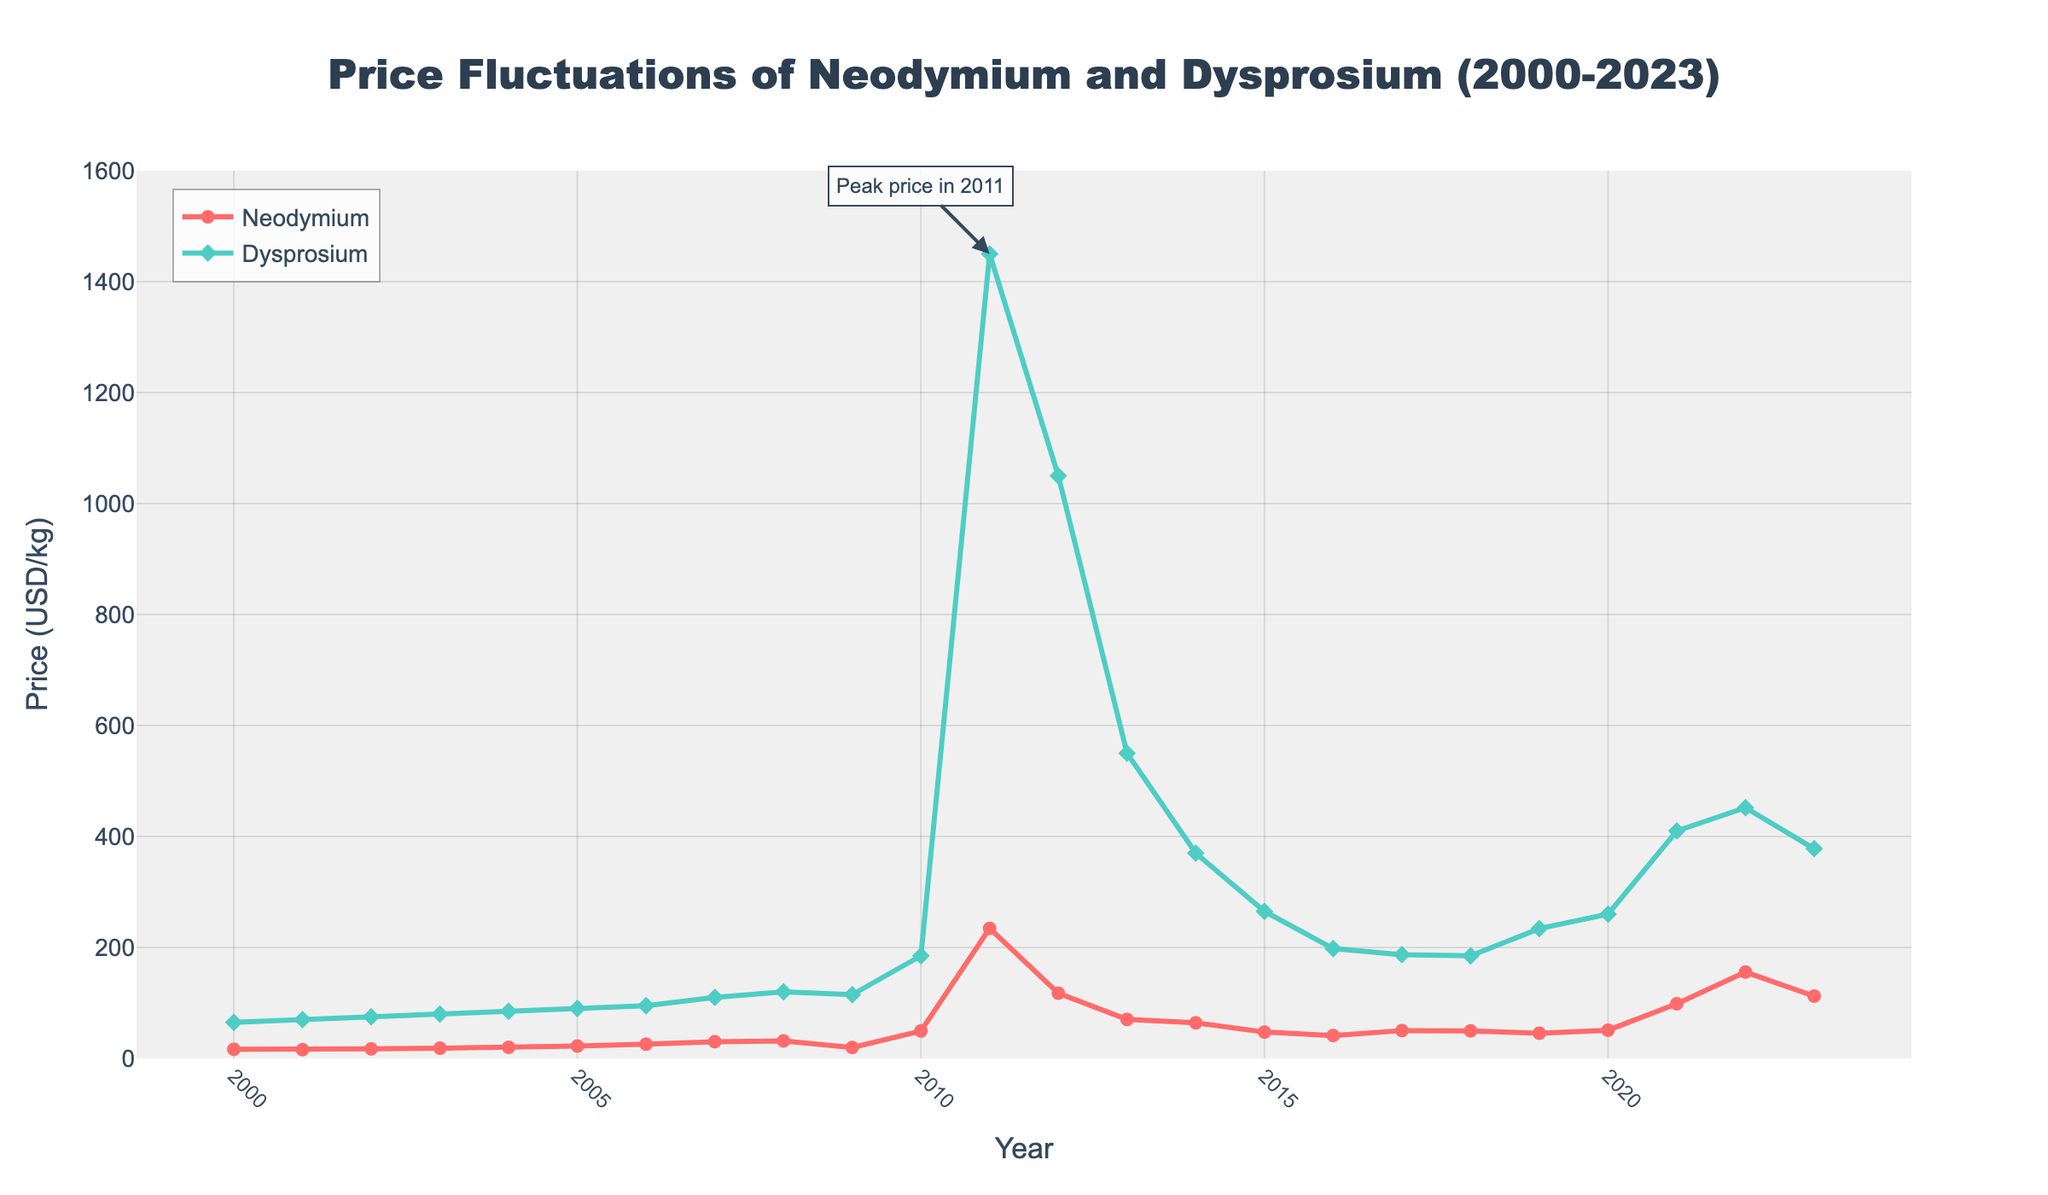What's the highest price of Dysprosium observed between 2000 and 2023? The peak price is indicated by a marked annotation pointing to the year 2011, where the price of Dysprosium reaches 1450 USD/kg.
Answer: 1450 USD/kg In which year did Neodymium's price first exceed 100 USD/kg? Observing the trendline for Neodymium, the price first exceeds 100 USD/kg in the year 2021 reaching approximately 98.5 USD/kg.
Answer: 2021 How does the average price of Neodymium from 2000 to 2010 compare to that from 2011 to 2023? Calculate the average price of Neodymium in the periods 2000-2010 and 2011-2023 separately. The former has an average around 24.23 USD/kg, and the latter significantly higher due to the spike with an average around 83.47 USD/kg.
Answer: Higher in 2011-2023 Which year showed the greatest increase in Dysprosium’s price compared to the previous year? By examining the steepest slope in Dysprosium's price line, the largest increase occurred between 2010 and 2011, where the price jumped from 185 USD/kg to 1450 USD/kg.
Answer: 2011 Compare the prices of Neodymium and Dysprosium in the year 2009. Which was higher and by how much? In 2009, Dysprosium was priced at 115 USD/kg and Neodymium at 19.8 USD/kg. Dysprosium was higher by 95.2 USD/kg.
Answer: Dysprosium by 95.2 USD/kg What is the general trend of Neodymium's price between 2000 and 2023? Neodymium's price generally increased from 2000 to 2011, then experienced a sharp decline until 2015, and later showed a gradual upward trend again.
Answer: Increasing trend How much did the price of Neodymium drop from its peak in 2011 to the year 2013? Neodymium's peak price was 234.4 USD/kg in 2011, and it dropped to 70.3 USD/kg in 2013. The difference is 164.1 USD/kg.
Answer: 164.1 USD/kg Identify the years where both Neodymium and Dysprosium experienced a price decline compared to the previous year. Both metals show a simultaneous price decline in the years 2012-2013 and 2014-2015.
Answer: 2012-2013, 2014-2015 How did the prices of Neodymium and Dysprosium change from 2022 to 2023? From 2022 to 2023, Neodymium's price decreased from 155.7 USD/kg to 112.3 USD/kg, while Dysprosium's price also decreased from 452 USD/kg to 378 USD/kg.
Answer: Both decreased What can you infer about the price volatility of Dysprosium as compared to Neodymium? Dysprosium shows more considerable price volatility, peaking sharply in 2011 ($1450/kg) compared to Neodymium's highest price in 2011 ($234.4/kg).
Answer: More volatile 